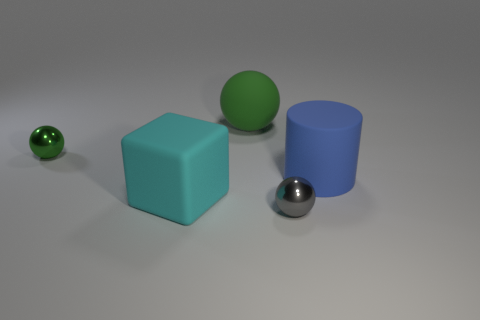Is the number of large blocks right of the large cyan cube less than the number of things that are on the left side of the green shiny thing?
Your answer should be very brief. No. What material is the small object behind the tiny thing that is on the right side of the small ball that is behind the gray shiny thing?
Ensure brevity in your answer.  Metal. There is a object that is in front of the blue cylinder and left of the gray metal thing; what size is it?
Keep it short and to the point. Large. How many cylinders are either tiny red matte things or gray objects?
Give a very brief answer. 0. There is a rubber block that is the same size as the cylinder; what color is it?
Provide a short and direct response. Cyan. Are there any other things that are the same shape as the green matte thing?
Offer a very short reply. Yes. There is another rubber thing that is the same shape as the small green object; what is its color?
Give a very brief answer. Green. What number of objects are either large brown rubber blocks or green spheres on the right side of the small green shiny thing?
Give a very brief answer. 1. Are there fewer large green rubber objects that are in front of the big blue rubber thing than big purple rubber spheres?
Your answer should be compact. No. There is a matte object that is to the right of the tiny metallic object in front of the blue cylinder that is right of the green matte thing; what is its size?
Offer a very short reply. Large. 